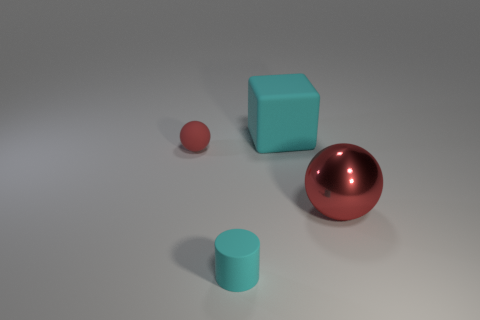Is the material of the big block the same as the red sphere that is to the right of the tiny cylinder?
Provide a short and direct response. No. How many objects are either balls or big red metallic objects?
Provide a succinct answer. 2. Are there any small blue rubber things?
Ensure brevity in your answer.  No. There is a small thing that is on the right side of the red object to the left of the small cylinder; what shape is it?
Offer a very short reply. Cylinder. What number of objects are red objects that are to the right of the large cyan rubber block or large things behind the large metal object?
Provide a short and direct response. 2. What is the material of the thing that is the same size as the cyan rubber block?
Your answer should be compact. Metal. The matte ball has what color?
Your answer should be compact. Red. There is a object that is both behind the large ball and to the right of the tiny red sphere; what is its material?
Your answer should be very brief. Rubber. There is a small rubber cylinder right of the red sphere that is left of the red metal sphere; are there any red objects right of it?
Your answer should be compact. Yes. What size is the matte thing that is the same color as the large matte block?
Ensure brevity in your answer.  Small. 